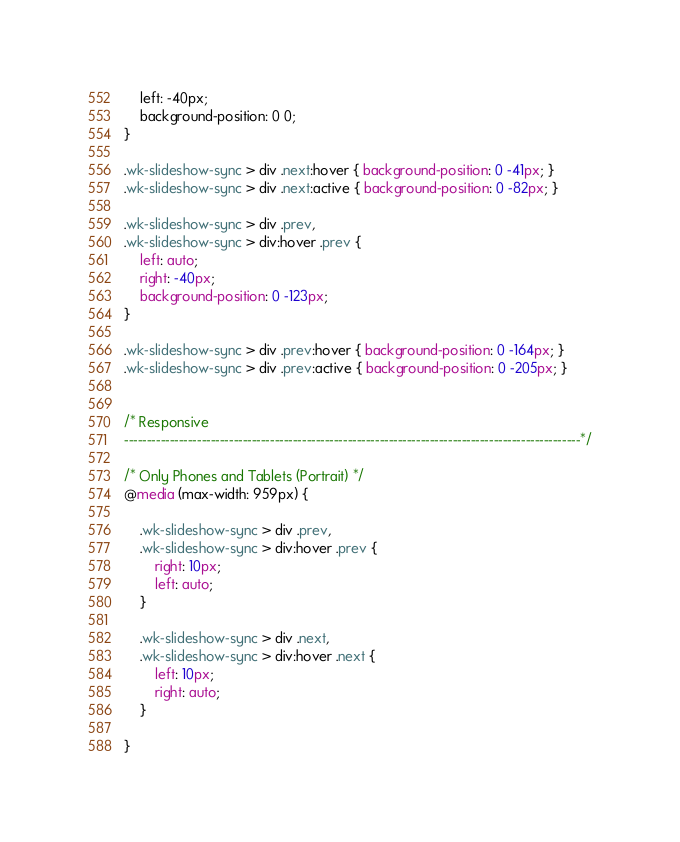Convert code to text. <code><loc_0><loc_0><loc_500><loc_500><_CSS_>	left: -40px;
	background-position: 0 0;
}

.wk-slideshow-sync > div .next:hover { background-position: 0 -41px; }
.wk-slideshow-sync > div .next:active { background-position: 0 -82px; }

.wk-slideshow-sync > div .prev,
.wk-slideshow-sync > div:hover .prev {
	left: auto;
	right: -40px;
	background-position: 0 -123px;
}

.wk-slideshow-sync > div .prev:hover { background-position: 0 -164px; }
.wk-slideshow-sync > div .prev:active { background-position: 0 -205px; }


/* Responsive
----------------------------------------------------------------------------------------------------*/

/* Only Phones and Tablets (Portrait) */
@media (max-width: 959px) {

	.wk-slideshow-sync > div .prev,
	.wk-slideshow-sync > div:hover .prev { 
		right: 10px;
		left: auto; 
	}

	.wk-slideshow-sync > div .next,
	.wk-slideshow-sync > div:hover .next { 
		left: 10px;
		right: auto; 
	}

}</code> 